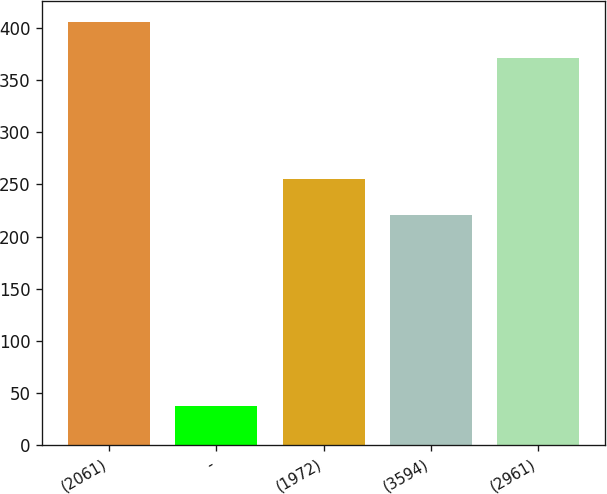<chart> <loc_0><loc_0><loc_500><loc_500><bar_chart><fcel>(2061)<fcel>-<fcel>(1972)<fcel>(3594)<fcel>(2961)<nl><fcel>406.09<fcel>37.7<fcel>255.59<fcel>221<fcel>371.5<nl></chart> 